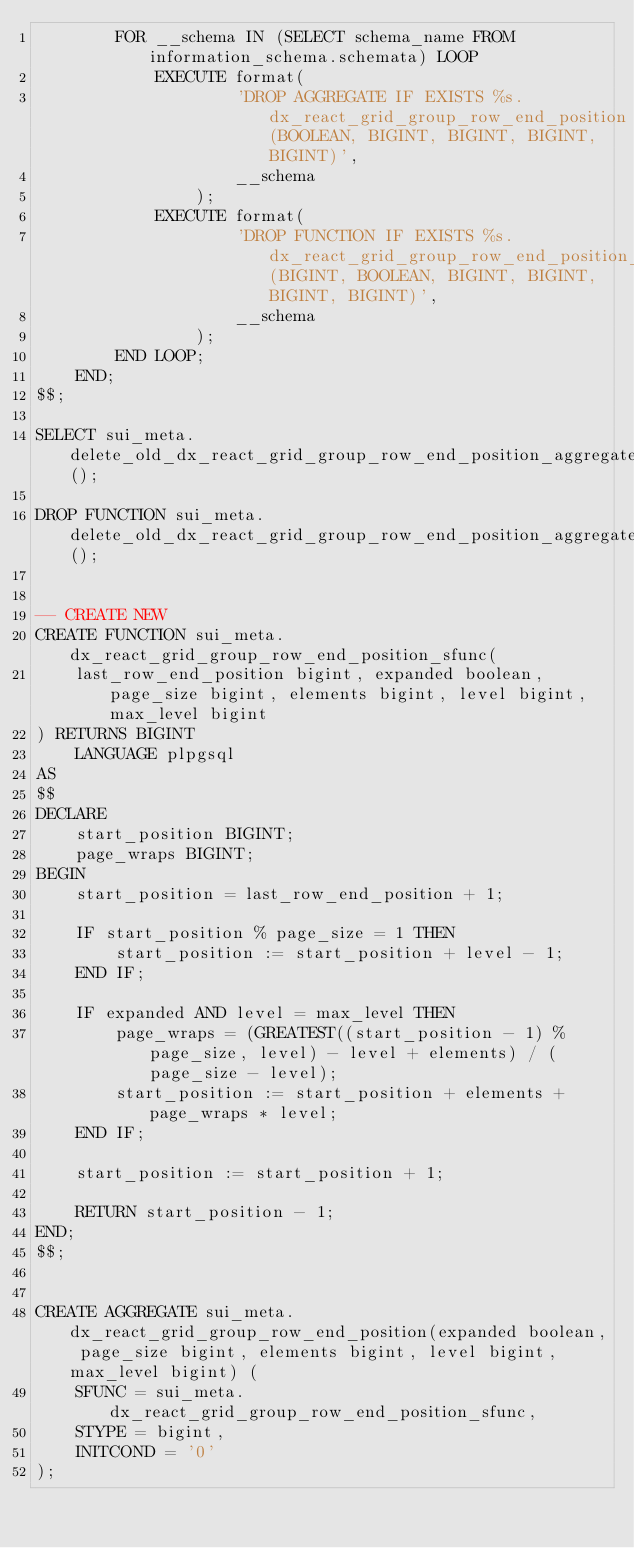Convert code to text. <code><loc_0><loc_0><loc_500><loc_500><_SQL_>        FOR __schema IN (SELECT schema_name FROM information_schema.schemata) LOOP
            EXECUTE format(
                    'DROP AGGREGATE IF EXISTS %s.dx_react_grid_group_row_end_position(BOOLEAN, BIGINT, BIGINT, BIGINT, BIGINT)',
                    __schema
                );
            EXECUTE format(
                    'DROP FUNCTION IF EXISTS %s.dx_react_grid_group_row_end_position_sfunc(BIGINT, BOOLEAN, BIGINT, BIGINT, BIGINT, BIGINT)',
                    __schema
                );
        END LOOP;
    END;
$$;

SELECT sui_meta.delete_old_dx_react_grid_group_row_end_position_aggregate();

DROP FUNCTION sui_meta.delete_old_dx_react_grid_group_row_end_position_aggregate();


-- CREATE NEW
CREATE FUNCTION sui_meta.dx_react_grid_group_row_end_position_sfunc(
    last_row_end_position bigint, expanded boolean, page_size bigint, elements bigint, level bigint, max_level bigint
) RETURNS BIGINT
    LANGUAGE plpgsql
AS
$$
DECLARE
    start_position BIGINT;
    page_wraps BIGINT;
BEGIN
    start_position = last_row_end_position + 1;

    IF start_position % page_size = 1 THEN
        start_position := start_position + level - 1;
    END IF;

    IF expanded AND level = max_level THEN
        page_wraps = (GREATEST((start_position - 1) % page_size, level) - level + elements) / (page_size - level);
        start_position := start_position + elements + page_wraps * level;
    END IF;

    start_position := start_position + 1;

    RETURN start_position - 1;
END;
$$;


CREATE AGGREGATE sui_meta.dx_react_grid_group_row_end_position(expanded boolean, page_size bigint, elements bigint, level bigint, max_level bigint) (
    SFUNC = sui_meta.dx_react_grid_group_row_end_position_sfunc,
    STYPE = bigint,
    INITCOND = '0'
);

</code> 